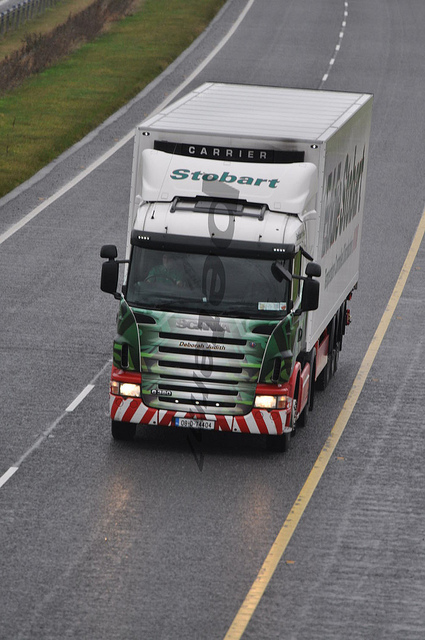Please identify all text content in this image. CARRIER Stobart 